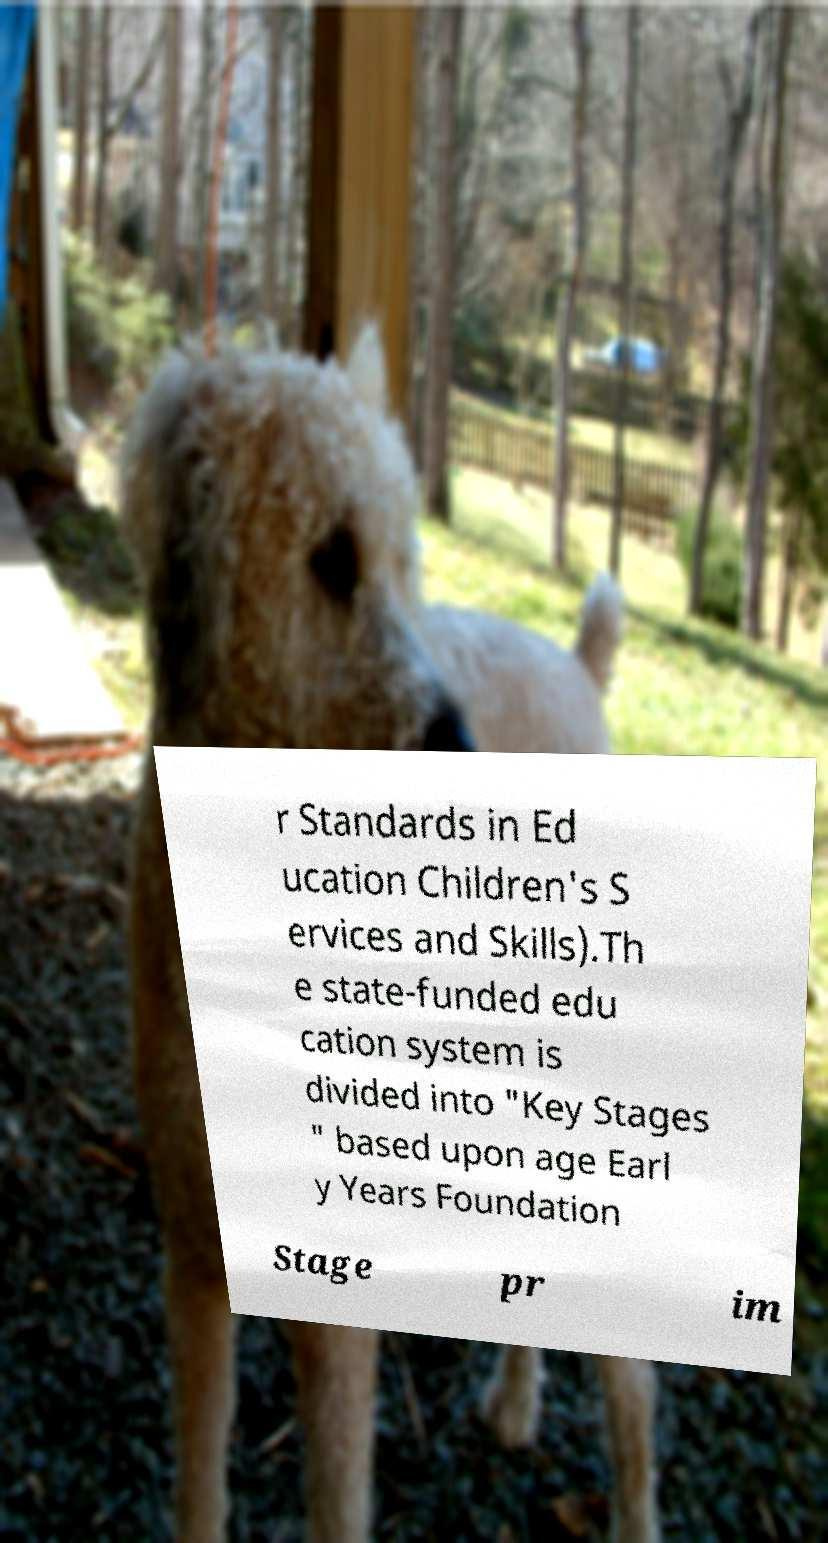Please read and relay the text visible in this image. What does it say? r Standards in Ed ucation Children's S ervices and Skills).Th e state-funded edu cation system is divided into "Key Stages " based upon age Earl y Years Foundation Stage pr im 